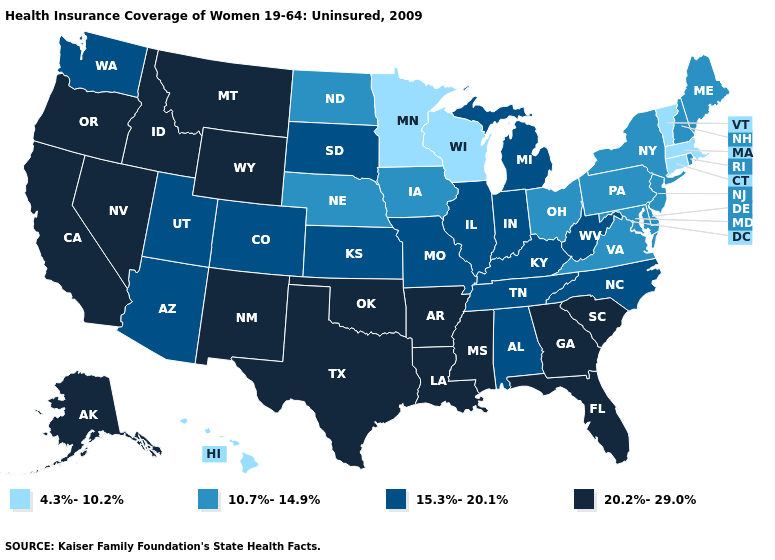Among the states that border South Carolina , does North Carolina have the highest value?
Quick response, please. No. Name the states that have a value in the range 4.3%-10.2%?
Answer briefly. Connecticut, Hawaii, Massachusetts, Minnesota, Vermont, Wisconsin. Is the legend a continuous bar?
Concise answer only. No. Name the states that have a value in the range 15.3%-20.1%?
Quick response, please. Alabama, Arizona, Colorado, Illinois, Indiana, Kansas, Kentucky, Michigan, Missouri, North Carolina, South Dakota, Tennessee, Utah, Washington, West Virginia. Does West Virginia have the lowest value in the South?
Short answer required. No. Does Montana have the lowest value in the West?
Short answer required. No. Name the states that have a value in the range 10.7%-14.9%?
Give a very brief answer. Delaware, Iowa, Maine, Maryland, Nebraska, New Hampshire, New Jersey, New York, North Dakota, Ohio, Pennsylvania, Rhode Island, Virginia. How many symbols are there in the legend?
Quick response, please. 4. Name the states that have a value in the range 20.2%-29.0%?
Short answer required. Alaska, Arkansas, California, Florida, Georgia, Idaho, Louisiana, Mississippi, Montana, Nevada, New Mexico, Oklahoma, Oregon, South Carolina, Texas, Wyoming. Which states hav the highest value in the West?
Concise answer only. Alaska, California, Idaho, Montana, Nevada, New Mexico, Oregon, Wyoming. Name the states that have a value in the range 20.2%-29.0%?
Concise answer only. Alaska, Arkansas, California, Florida, Georgia, Idaho, Louisiana, Mississippi, Montana, Nevada, New Mexico, Oklahoma, Oregon, South Carolina, Texas, Wyoming. What is the lowest value in the MidWest?
Concise answer only. 4.3%-10.2%. Name the states that have a value in the range 10.7%-14.9%?
Concise answer only. Delaware, Iowa, Maine, Maryland, Nebraska, New Hampshire, New Jersey, New York, North Dakota, Ohio, Pennsylvania, Rhode Island, Virginia. What is the value of Louisiana?
Quick response, please. 20.2%-29.0%. 